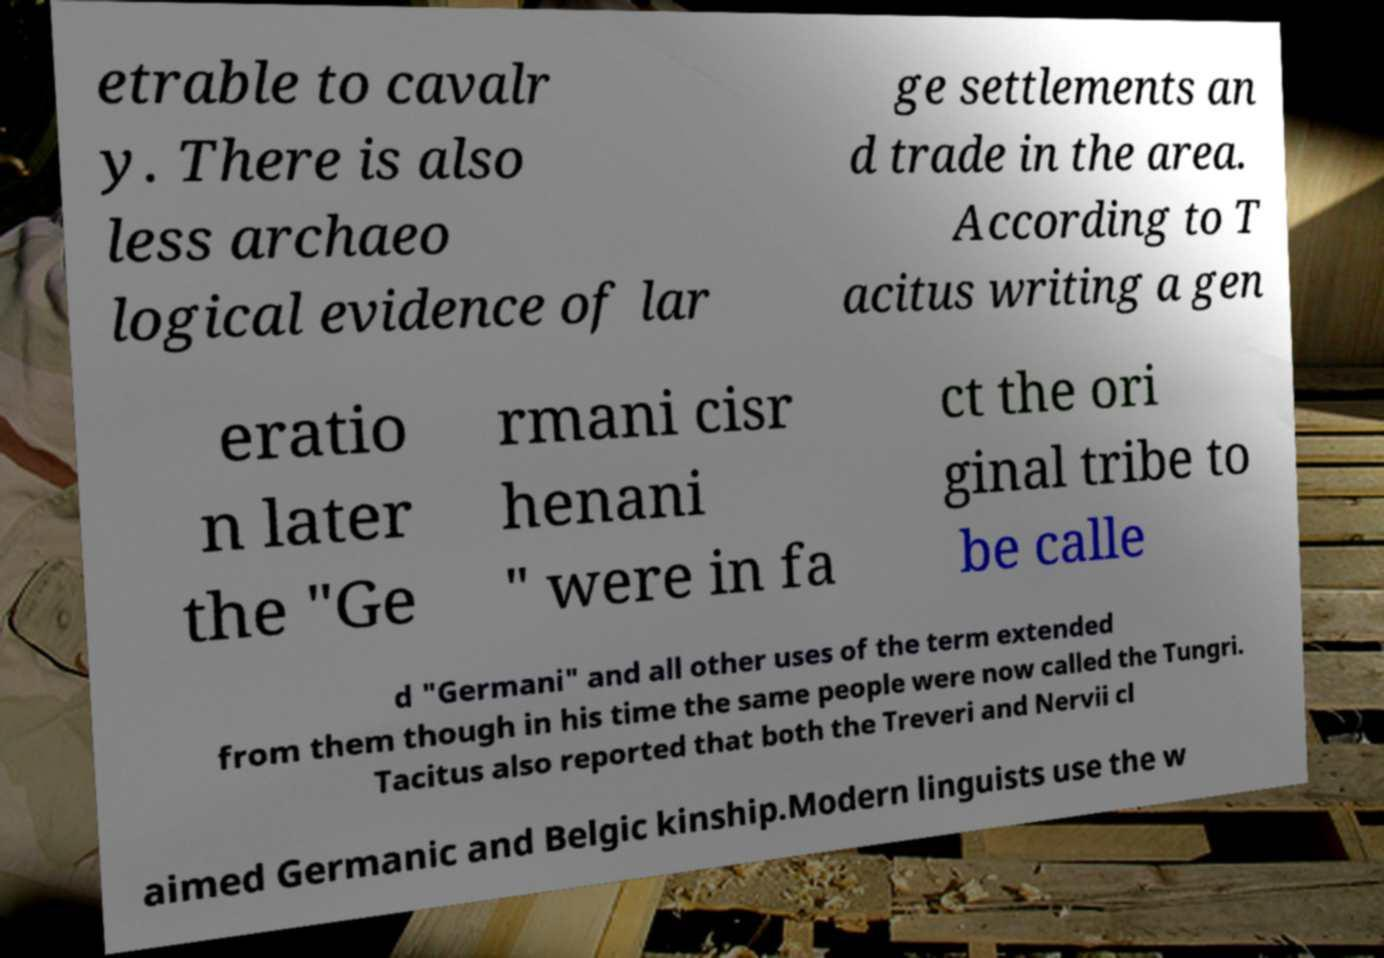Please read and relay the text visible in this image. What does it say? etrable to cavalr y. There is also less archaeo logical evidence of lar ge settlements an d trade in the area. According to T acitus writing a gen eratio n later the "Ge rmani cisr henani " were in fa ct the ori ginal tribe to be calle d "Germani" and all other uses of the term extended from them though in his time the same people were now called the Tungri. Tacitus also reported that both the Treveri and Nervii cl aimed Germanic and Belgic kinship.Modern linguists use the w 